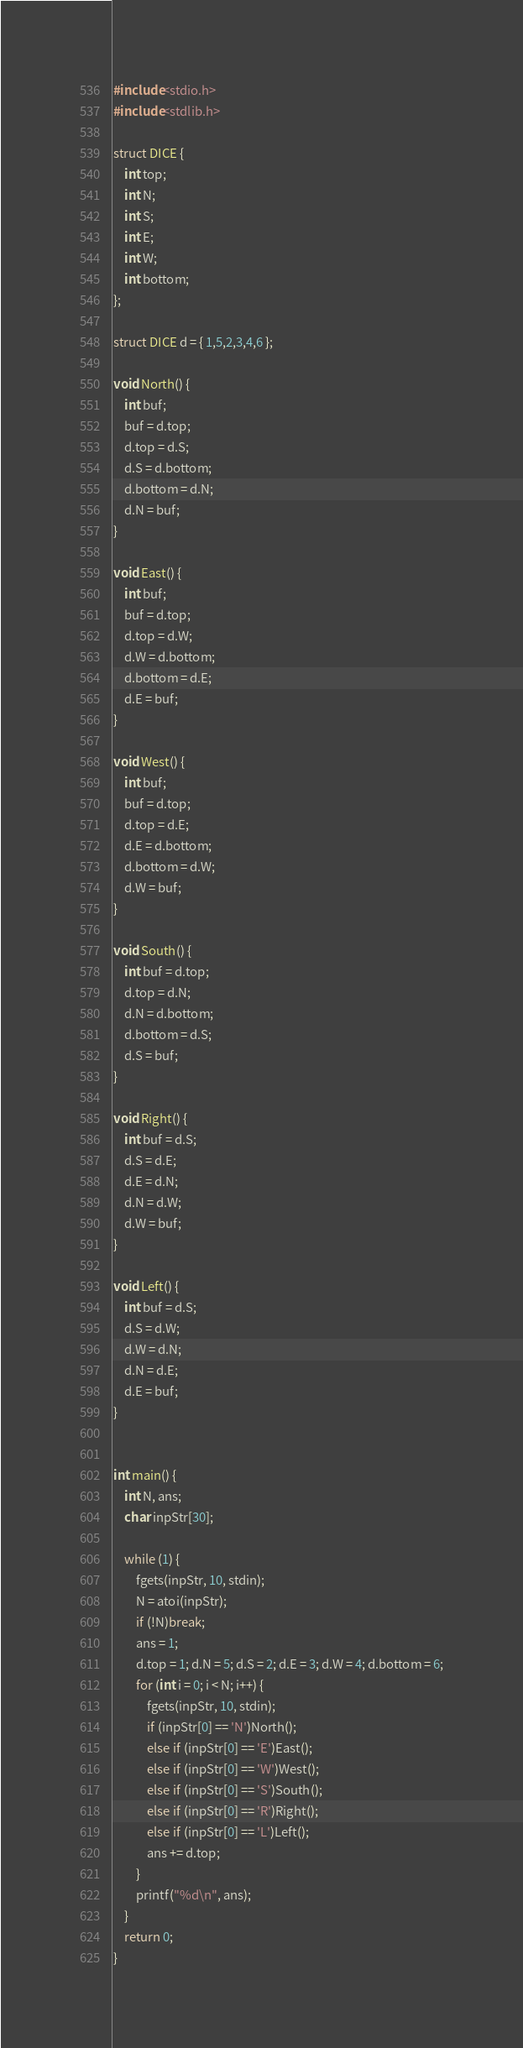<code> <loc_0><loc_0><loc_500><loc_500><_C_>#include<stdio.h>
#include<stdlib.h>

struct DICE {
	int top;
	int N;
	int S;
	int E;
	int W;
	int bottom;
};

struct DICE d = { 1,5,2,3,4,6 };

void North() {
	int buf;
	buf = d.top;
	d.top = d.S;
	d.S = d.bottom;
	d.bottom = d.N;
	d.N = buf;
}

void East() {
	int buf;
	buf = d.top;
	d.top = d.W;
	d.W = d.bottom;
	d.bottom = d.E;
	d.E = buf;
}

void West() {
	int buf;
	buf = d.top;
	d.top = d.E;
	d.E = d.bottom;
	d.bottom = d.W;
	d.W = buf;
}

void South() {
	int buf = d.top;
	d.top = d.N;
	d.N = d.bottom;
	d.bottom = d.S;
	d.S = buf;
}

void Right() {
	int buf = d.S;
	d.S = d.E;
	d.E = d.N;
	d.N = d.W;
	d.W = buf;
}

void Left() {
	int buf = d.S;
	d.S = d.W;
	d.W = d.N;
	d.N = d.E;
	d.E = buf;
}


int main() {
	int N, ans;
	char inpStr[30];
	
	while (1) {
		fgets(inpStr, 10, stdin);
		N = atoi(inpStr);
		if (!N)break;
		ans = 1;
		d.top = 1; d.N = 5; d.S = 2; d.E = 3; d.W = 4; d.bottom = 6;
		for (int i = 0; i < N; i++) {
			fgets(inpStr, 10, stdin);
			if (inpStr[0] == 'N')North();
			else if (inpStr[0] == 'E')East();
			else if (inpStr[0] == 'W')West();
			else if (inpStr[0] == 'S')South();
			else if (inpStr[0] == 'R')Right();
			else if (inpStr[0] == 'L')Left();
			ans += d.top;
		}
		printf("%d\n", ans);
	}
	return 0;
}
</code> 